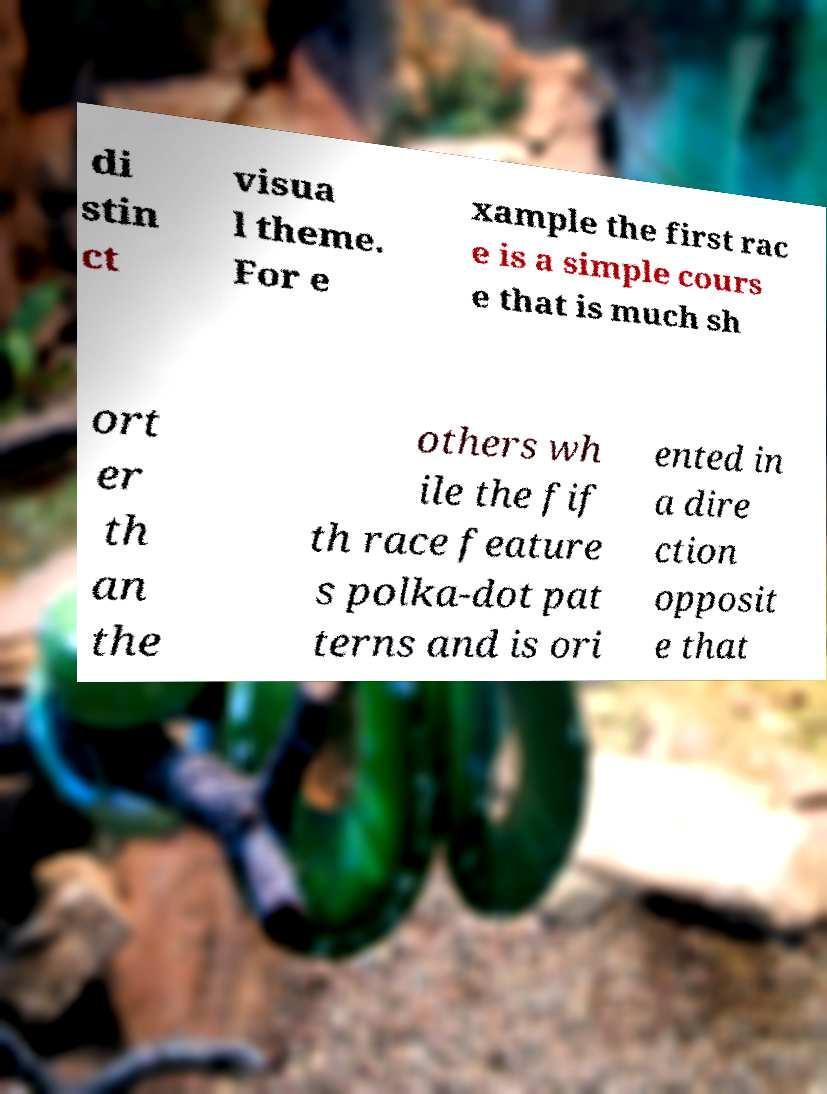Can you accurately transcribe the text from the provided image for me? di stin ct visua l theme. For e xample the first rac e is a simple cours e that is much sh ort er th an the others wh ile the fif th race feature s polka-dot pat terns and is ori ented in a dire ction opposit e that 